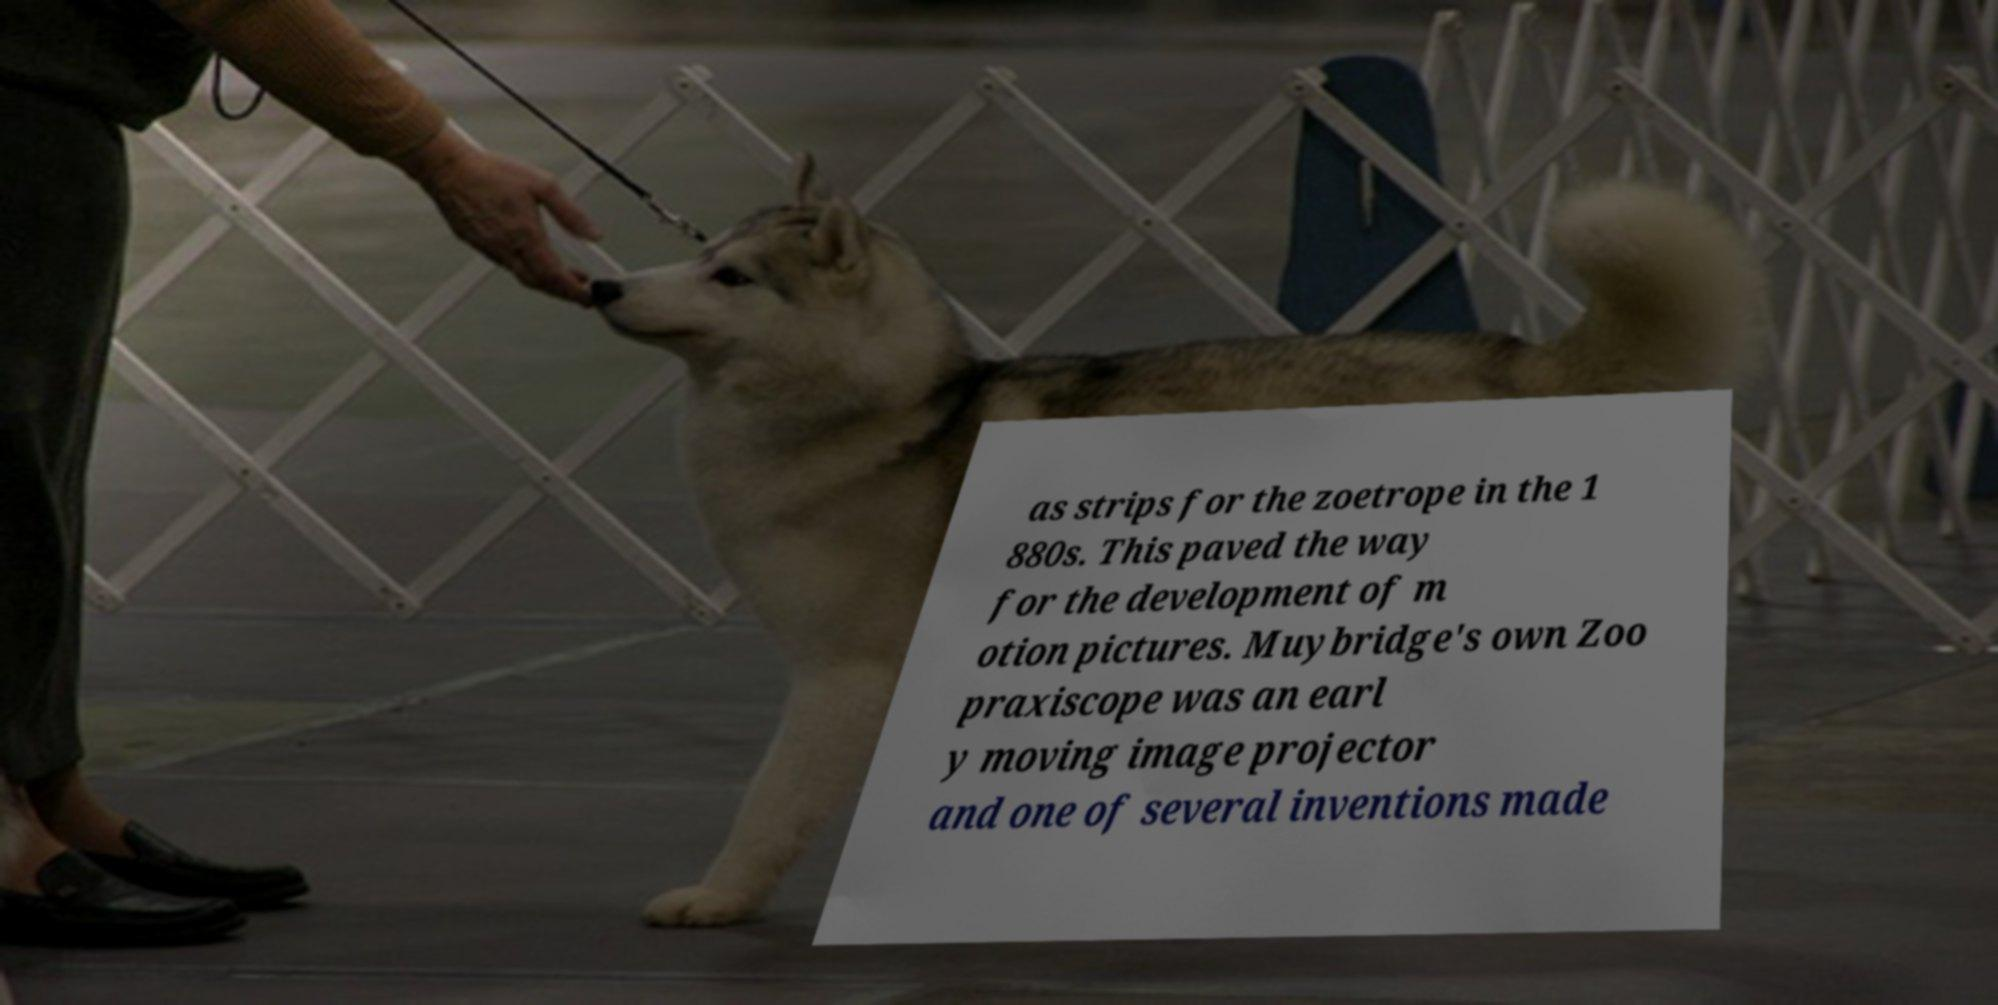I need the written content from this picture converted into text. Can you do that? as strips for the zoetrope in the 1 880s. This paved the way for the development of m otion pictures. Muybridge's own Zoo praxiscope was an earl y moving image projector and one of several inventions made 